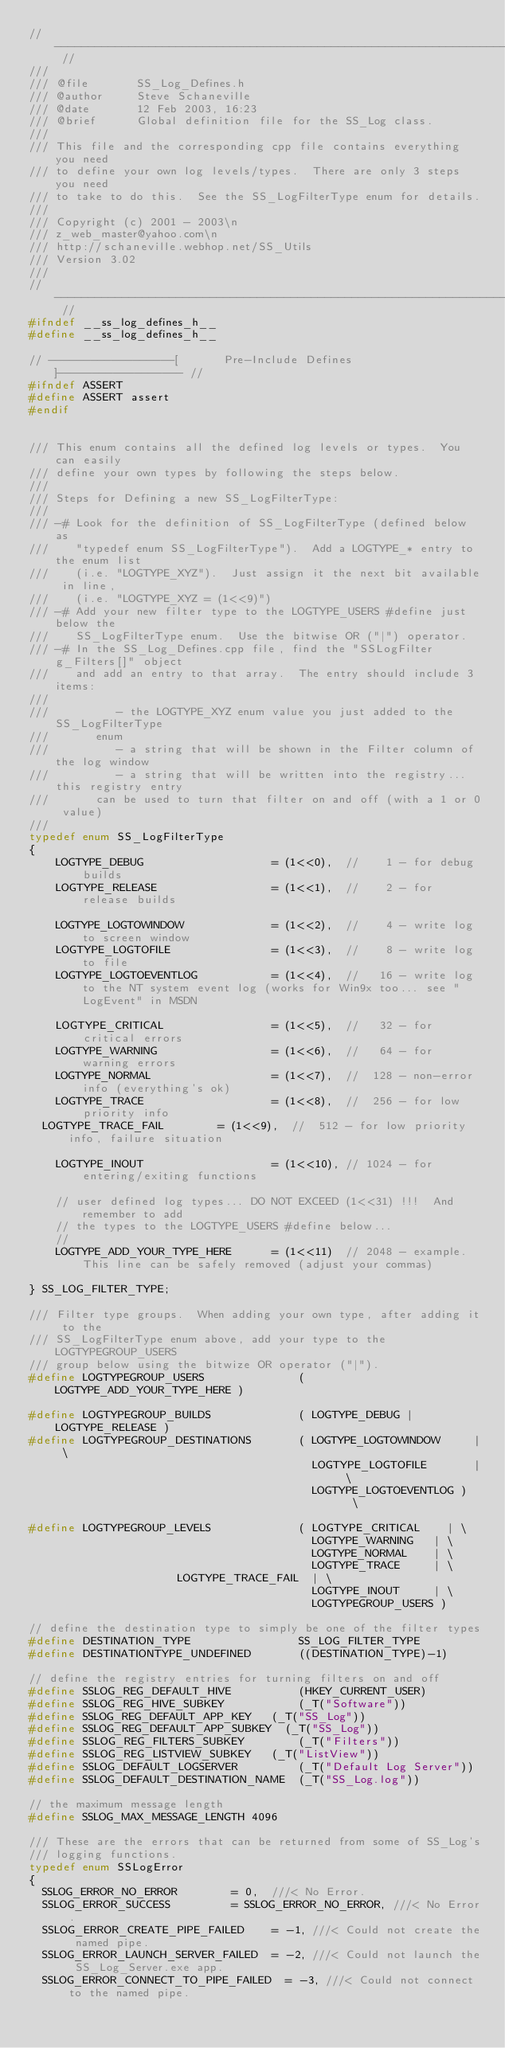Convert code to text. <code><loc_0><loc_0><loc_500><loc_500><_C_>// ----------------------------------------------------------------------- //
///
/// @file       SS_Log_Defines.h
/// @author     Steve Schaneville
/// @date       12 Feb 2003, 16:23
/// @brief      Global definition file for the SS_Log class.
///
/// This file and the corresponding cpp file contains everything you need
/// to define your own log levels/types.  There are only 3 steps you need
/// to take to do this.  See the SS_LogFilterType enum for details.
///
/// Copyright (c) 2001 - 2003\n
/// z_web_master@yahoo.com\n
/// http://schaneville.webhop.net/SS_Utils
/// Version 3.02
///
// ----------------------------------------------------------------------- //
#ifndef __ss_log_defines_h__
#define __ss_log_defines_h__

// ------------------[       Pre-Include Defines       ]------------------ //
#ifndef ASSERT
#define ASSERT assert
#endif


/// This enum contains all the defined log levels or types.  You can easily
/// define your own types by following the steps below.
///
/// Steps for Defining a new SS_LogFilterType:
///
/// -# Look for the definition of SS_LogFilterType (defined below as
///    "typedef enum SS_LogFilterType").  Add a LOGTYPE_* entry to the enum list
///    (i.e. "LOGTYPE_XYZ").  Just assign it the next bit available in line,
///    (i.e. "LOGTYPE_XYZ = (1<<9)")
/// -# Add your new filter type to the LOGTYPE_USERS #define just below the
///    SS_LogFilterType enum.  Use the bitwise OR ("|") operator.
/// -# In the SS_Log_Defines.cpp file, find the "SSLogFilter g_Filters[]" object
///    and add an entry to that array.  The entry should include 3 items:
///
///          - the LOGTYPE_XYZ enum value you just added to the SS_LogFilterType
///				enum
///          - a string that will be shown in the Filter column of the log window
///          - a string that will be written into the registry... this registry entry
///				can be used to turn that filter on and off (with a 1 or 0 value)
///
typedef enum SS_LogFilterType
{
    LOGTYPE_DEBUG                   = (1<<0),  //    1 - for debug builds
    LOGTYPE_RELEASE                 = (1<<1),  //    2 - for release builds

    LOGTYPE_LOGTOWINDOW             = (1<<2),  //    4 - write log to screen window
    LOGTYPE_LOGTOFILE               = (1<<3),  //    8 - write log to file
    LOGTYPE_LOGTOEVENTLOG           = (1<<4),  //   16 - write log to the NT system event log (works for Win9x too... see "LogEvent" in MSDN

    LOGTYPE_CRITICAL                = (1<<5),  //   32 - for critical errors
    LOGTYPE_WARNING                 = (1<<6),  //   64 - for warning errors
    LOGTYPE_NORMAL                  = (1<<7),  //  128 - non-error info (everything's ok)
    LOGTYPE_TRACE                   = (1<<8),  //  256 - for low priority info
	LOGTYPE_TRACE_FAIL				= (1<<9),  //  512 - for low priority info, failure situation

    LOGTYPE_INOUT                   = (1<<10), // 1024 - for entering/exiting functions

    // user defined log types... DO NOT EXCEED (1<<31) !!!  And remember to add
    // the types to the LOGTYPE_USERS #define below...
    //
    LOGTYPE_ADD_YOUR_TYPE_HERE      = (1<<11)  // 2048 - example.  This line can be safely removed (adjust your commas)

} SS_LOG_FILTER_TYPE;

/// Filter type groups.  When adding your own type, after adding it to the
/// SS_LogFilterType enum above, add your type to the LOGTYPEGROUP_USERS
/// group below using the bitwize OR operator ("|").
#define LOGTYPEGROUP_USERS              ( LOGTYPE_ADD_YOUR_TYPE_HERE )

#define LOGTYPEGROUP_BUILDS             ( LOGTYPE_DEBUG | LOGTYPE_RELEASE )
#define LOGTYPEGROUP_DESTINATIONS       ( LOGTYPE_LOGTOWINDOW     | \
                                          LOGTYPE_LOGTOFILE       | \
                                          LOGTYPE_LOGTOEVENTLOG )   \

#define LOGTYPEGROUP_LEVELS             ( LOGTYPE_CRITICAL		| \
                                          LOGTYPE_WARNING		| \
                                          LOGTYPE_NORMAL		| \
                                          LOGTYPE_TRACE			| \
										  LOGTYPE_TRACE_FAIL	| \
                                          LOGTYPE_INOUT			| \
                                          LOGTYPEGROUP_USERS )

// define the destination type to simply be one of the filter types
#define DESTINATION_TYPE                SS_LOG_FILTER_TYPE
#define DESTINATIONTYPE_UNDEFINED       ((DESTINATION_TYPE)-1)

// define the registry entries for turning filters on and off
#define SSLOG_REG_DEFAULT_HIVE          (HKEY_CURRENT_USER)
#define SSLOG_REG_HIVE_SUBKEY           (_T("Software"))
#define SSLOG_REG_DEFAULT_APP_KEY		(_T("SS_Log"))
#define SSLOG_REG_DEFAULT_APP_SUBKEY	(_T("SS_Log"))
#define SSLOG_REG_FILTERS_SUBKEY        (_T("Filters"))
#define SSLOG_REG_LISTVIEW_SUBKEY		(_T("ListView"))
#define SSLOG_DEFAULT_LOGSERVER         (_T("Default Log Server"))
#define SSLOG_DEFAULT_DESTINATION_NAME  (_T("SS_Log.log"))

// the maximum message length
#define SSLOG_MAX_MESSAGE_LENGTH 4096

/// These are the errors that can be returned from some of SS_Log's
/// logging functions.
typedef enum SSLogError
{
	SSLOG_ERROR_NO_ERROR				= 0,	///< No Error.
	SSLOG_ERROR_SUCCESS					= SSLOG_ERROR_NO_ERROR, ///< No Error.
	SSLOG_ERROR_CREATE_PIPE_FAILED		= -1,	///< Could not create the named pipe.
	SSLOG_ERROR_LAUNCH_SERVER_FAILED	= -2,	///< Could not launch the SS_Log_Server.exe app.
	SSLOG_ERROR_CONNECT_TO_PIPE_FAILED	= -3,	///< Could not connect to the named pipe.</code> 